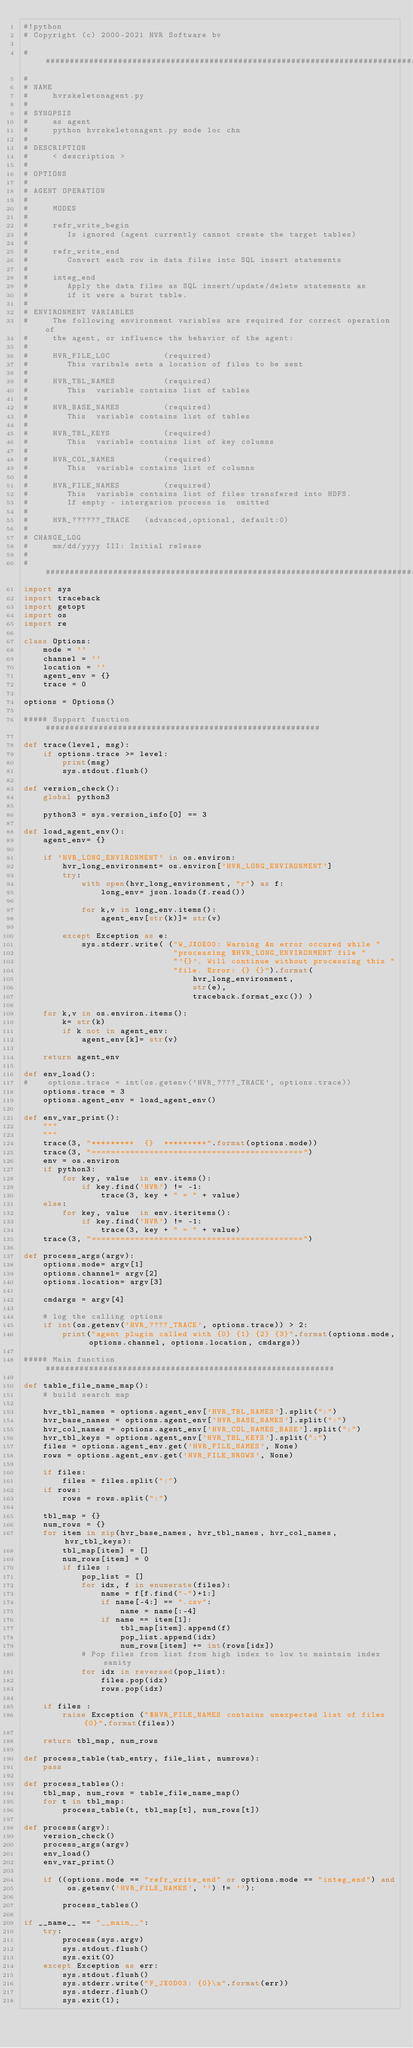<code> <loc_0><loc_0><loc_500><loc_500><_Python_>#!python
# Copyright (c) 2000-2021 HVR Software bv

################################################################################
# 
# NAME
#     hvrskeletonagent.py
#
# SYNOPSIS
#     as agent
#     python hvrskeletonagent.py mode loc chn
#   
# DESCRIPTION
#     < description >
#
# OPTIONS
#
# AGENT OPERATION
#
#     MODES
#
#     refr_write_begin
#        Is ignored (agent currently cannot create the target tables)
#
#     refr_write_end
#        Convert each row in data files into SQL insert statements 
#
#     integ_end
#        Apply the data files as SQL insert/update/delete statements as 
#        if it were a burst table.
#
# ENVIRONMENT VARIABLES
#     The following environment variables are required for correct operation of
#     the agent, or influence the behavior of the agent:
#
#     HVR_FILE_LOC           (required)
#        This varibale sets a location of files to be sent
#  
#     HVR_TBL_NAMES          (required)       
#        This  variable contains list of tables
#  
#     HVR_BASE_NAMES         (required)       
#        This  variable contains list of tables
#  
#     HVR_TBL_KEYS           (required)       
#        This  variable contains list of key columns
#  
#     HVR_COL_NAMES          (required)       
#        This  variable contains list of columns
#  
#     HVR_FILE_NAMES         (required)
#        This  variable contains list of files transfered into HDFS.
#        If empty - intergarion process is  omitted
#
#     HVR_??????_TRACE   (advanced,optional, default:0)
#
# CHANGE_LOG
#     mm/dd/yyyy III: Initial release
#
################################################################################
import sys
import traceback
import getopt
import os
import re

class Options:
    mode = ''
    channel = ''
    location = ''
    agent_env = {}
    trace = 0

options = Options()

##### Support function #########################################################

def trace(level, msg):
    if options.trace >= level:
        print(msg)
        sys.stdout.flush() 

def version_check():
    global python3

    python3 = sys.version_info[0] == 3
    
def load_agent_env():
    agent_env= {}

    if 'HVR_LONG_ENVIRONMENT' in os.environ:
        hvr_long_environment= os.environ['HVR_LONG_ENVIRONMENT']
        try:
            with open(hvr_long_environment, "r") as f:
                long_env= json.loads(f.read())

            for k,v in long_env.items():
                agent_env[str(k)]= str(v)

        except Exception as e:
            sys.stderr.write( ("W_JX0E00: Warning An error occured while "
                               "processing $HVR_LONG_ENVIRONMENT file "
                               "'{}'. Will continue without processing this "
                               "file. Error: {} {}").format(
                                   hvr_long_environment,
                                   str(e),
                                   traceback.format_exc()) )

    for k,v in os.environ.items():
        k= str(k)
        if k not in agent_env:
            agent_env[k]= str(v)

    return agent_env

def env_load():
#    options.trace = int(os.getenv('HVR_????_TRACE', options.trace))
    options.trace = 3
    options.agent_env = load_agent_env()
   
def env_var_print():
    """
    """
    trace(3, "*********  {}  *********".format(options.mode))
    trace(3, "============================================")
    env = os.environ
    if python3:
        for key, value  in env.items():
            if key.find('HVR') != -1:
                trace(3, key + " = " + value)
    else:
        for key, value  in env.iteritems():
            if key.find('HVR') != -1:
                trace(3, key + " = " + value)
    trace(3, "============================================")

def process_args(argv):
    options.mode= argv[1]
    options.channel= argv[2]
    options.location= argv[3]

    cmdargs = argv[4]
  
    # log the calling options
    if int(os.getenv('HVR_????_TRACE', options.trace)) > 2:
        print("agent plugin called with {0} {1} {2} {3}".format(options.mode, options.channel, options.location, cmdargs))

##### Main function ############################################################

def table_file_name_map():
    # build search map

    hvr_tbl_names = options.agent_env['HVR_TBL_NAMES'].split(":")
    hvr_base_names = options.agent_env['HVR_BASE_NAMES'].split(":")
    hvr_col_names = options.agent_env['HVR_COL_NAMES_BASE'].split(":")
    hvr_tbl_keys = options.agent_env['HVR_TBL_KEYS'].split(":")
    files = options.agent_env.get('HVR_FILE_NAMES', None)
    rows = options.agent_env.get('HVR_FILE_NROWS', None)

    if files:
        files = files.split(":")
    if rows:
        rows = rows.split(":")

    tbl_map = {}
    num_rows = {}
    for item in zip(hvr_base_names, hvr_tbl_names, hvr_col_names, hvr_tbl_keys):
        tbl_map[item] = []
        num_rows[item] = 0
        if files :
            pop_list = []
            for idx, f in enumerate(files):
                name = f[f.find("-")+1:]
                if name[-4:] == ".csv":
                    name = name[:-4]
                if name == item[1]:
                    tbl_map[item].append(f)
                    pop_list.append(idx)
                    num_rows[item] += int(rows[idx])
            # Pop files from list from high index to low to maintain index sanity
            for idx in reversed(pop_list):
                files.pop(idx)
                rows.pop(idx)

    if files :  
        raise Exception ("$HVR_FILE_NAMES contains unexpected list of files {0}".format(files))

    return tbl_map, num_rows

def process_table(tab_entry, file_list, numrows):
    pass

def process_tables():
    tbl_map, num_rows = table_file_name_map()
    for t in tbl_map:
        process_table(t, tbl_map[t], num_rows[t])

def process(argv):
    version_check()
    process_args(argv)
    env_load()
    env_var_print()

    if ((options.mode == "refr_write_end" or options.mode == "integ_end") and
         os.getenv('HVR_FILE_NAMES', '') != ''):

        process_tables()

if __name__ == "__main__":
    try:
        process(sys.argv)
        sys.stdout.flush() 
        sys.exit(0) 
    except Exception as err:
        sys.stdout.flush() 
        sys.stderr.write("F_JX0D03: {0}\n".format(err))
        sys.stderr.flush()
        sys.exit(1);

</code> 